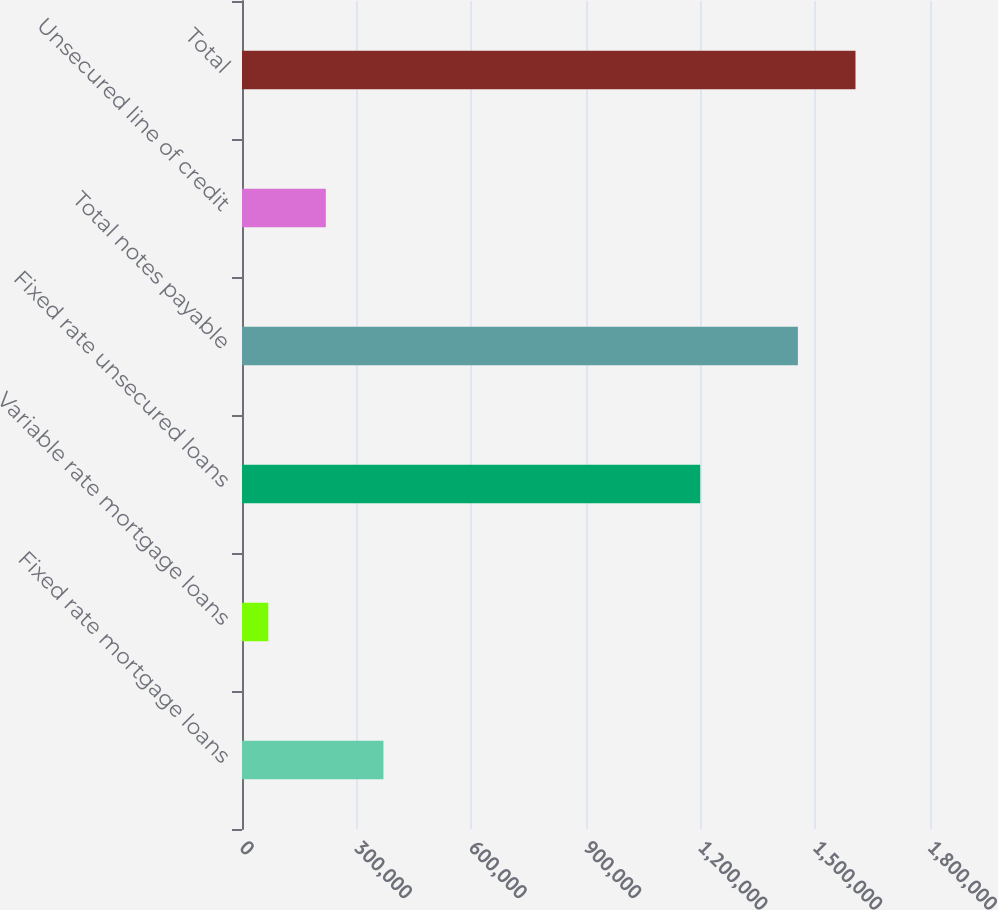Convert chart. <chart><loc_0><loc_0><loc_500><loc_500><bar_chart><fcel>Fixed rate mortgage loans<fcel>Variable rate mortgage loans<fcel>Fixed rate unsecured loans<fcel>Total notes payable<fcel>Unsecured line of credit<fcel>Total<nl><fcel>370007<fcel>68662<fcel>1.19883e+06<fcel>1.45439e+06<fcel>219334<fcel>1.60506e+06<nl></chart> 